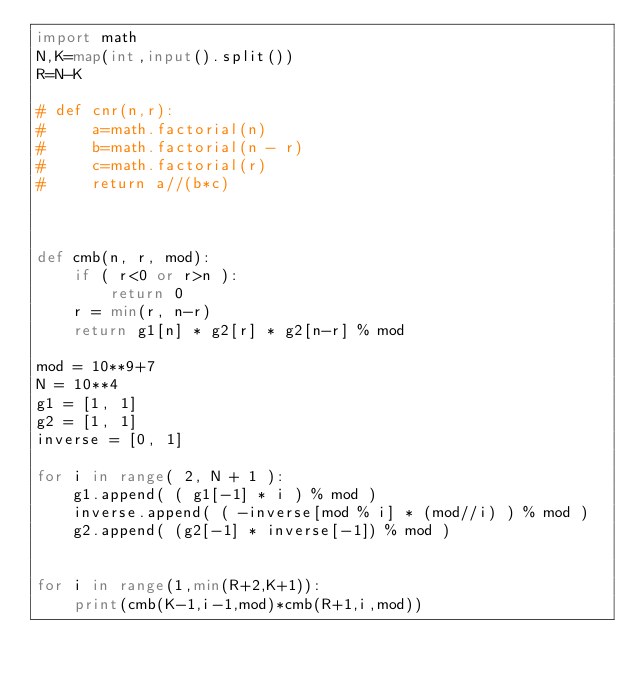<code> <loc_0><loc_0><loc_500><loc_500><_Python_>import math
N,K=map(int,input().split())
R=N-K
    
# def cnr(n,r):
#     a=math.factorial(n)
#     b=math.factorial(n - r)
#     c=math.factorial(r)
#     return a//(b*c)



def cmb(n, r, mod):
    if ( r<0 or r>n ):
        return 0
    r = min(r, n-r)
    return g1[n] * g2[r] * g2[n-r] % mod

mod = 10**9+7
N = 10**4
g1 = [1, 1]
g2 = [1, 1]
inverse = [0, 1]

for i in range( 2, N + 1 ):
    g1.append( ( g1[-1] * i ) % mod )
    inverse.append( ( -inverse[mod % i] * (mod//i) ) % mod )
    g2.append( (g2[-1] * inverse[-1]) % mod )


for i in range(1,min(R+2,K+1)):
    print(cmb(K-1,i-1,mod)*cmb(R+1,i,mod))
        
</code> 